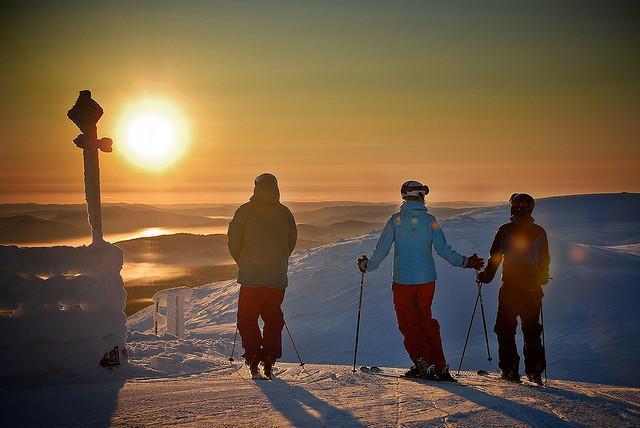How many people are there?
Give a very brief answer. 3. How many birds are in front of the bear?
Give a very brief answer. 0. 